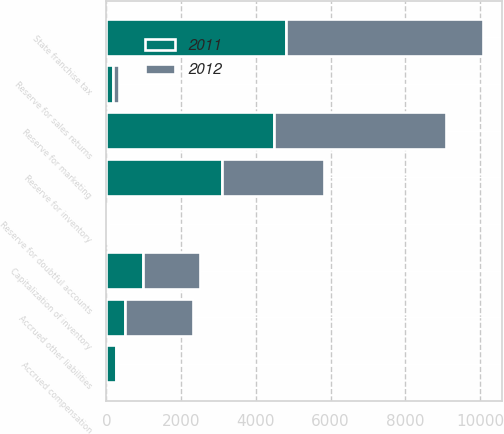Convert chart to OTSL. <chart><loc_0><loc_0><loc_500><loc_500><stacked_bar_chart><ecel><fcel>Reserve for sales returns<fcel>Reserve for doubtful accounts<fcel>Reserve for inventory<fcel>Reserve for marketing<fcel>Capitalization of inventory<fcel>State franchise tax<fcel>Accrued compensation<fcel>Accrued other liabilities<nl><fcel>2012<fcel>145<fcel>28<fcel>2753<fcel>4595<fcel>1524<fcel>5268<fcel>49<fcel>1825<nl><fcel>2011<fcel>186<fcel>42<fcel>3082<fcel>4485<fcel>972<fcel>4817<fcel>256<fcel>487<nl></chart> 